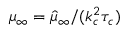Convert formula to latex. <formula><loc_0><loc_0><loc_500><loc_500>\mu _ { \infty } = \hat { \mu } _ { \infty } / ( k _ { c } ^ { 2 } \tau _ { c } )</formula> 